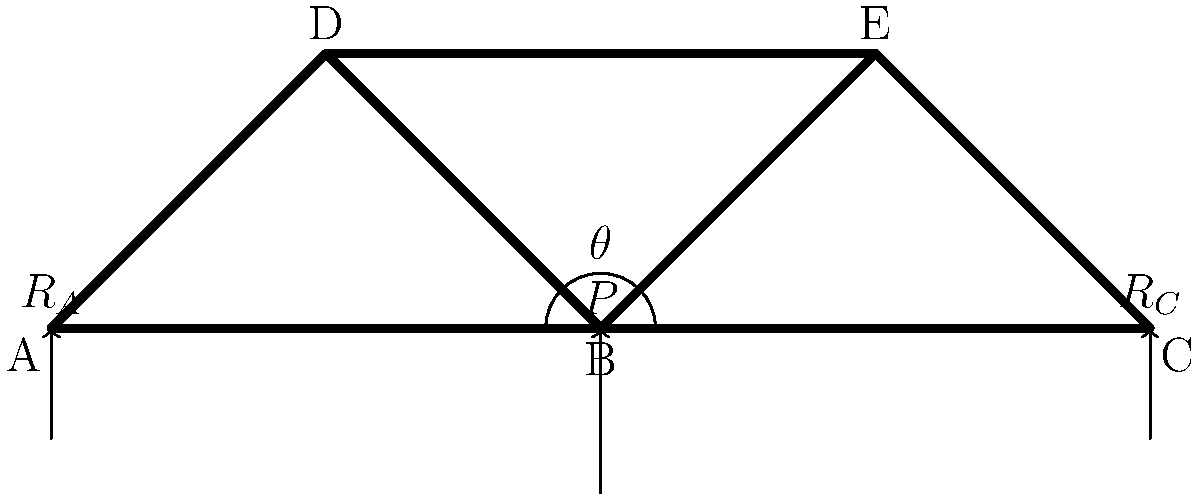Consider the truss bridge structure shown above. A vertical load $P = 100$ kN is applied at point B. The truss is supported by pin joints at A and C. If the angle $\theta = 45°$, determine the magnitude of the reaction force at support C $(R_C)$. To solve this problem, we'll use the method of joints and the equilibrium equations. Let's follow these steps:

1) First, we need to consider the entire truss as a free body and use the equilibrium equations:

   $\sum F_x = 0$
   $\sum F_y = 0$
   $\sum M_A = 0$ (taking moments about point A)

2) From $\sum F_y = 0$:
   $R_A + R_C - P = 0$
   $R_A + R_C = 100$ kN ... (Eq. 1)

3) Taking moments about A:
   $\sum M_A = 0$
   $R_C \cdot 200 - P \cdot 100 = 0$
   $200R_C = 100 \cdot 100$
   $R_C = 50$ kN

4) We can verify this result using Eq. 1:
   $R_A + 50 = 100$
   $R_A = 50$ kN

5) The question asks specifically for $R_C$, which we found to be 50 kN.

Note: The angle $\theta$ wasn't needed for this particular calculation, but it would be useful if we needed to determine the forces in the individual truss members.
Answer: $R_C = 50$ kN 